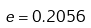<formula> <loc_0><loc_0><loc_500><loc_500>e = 0 . 2 0 5 6</formula> 